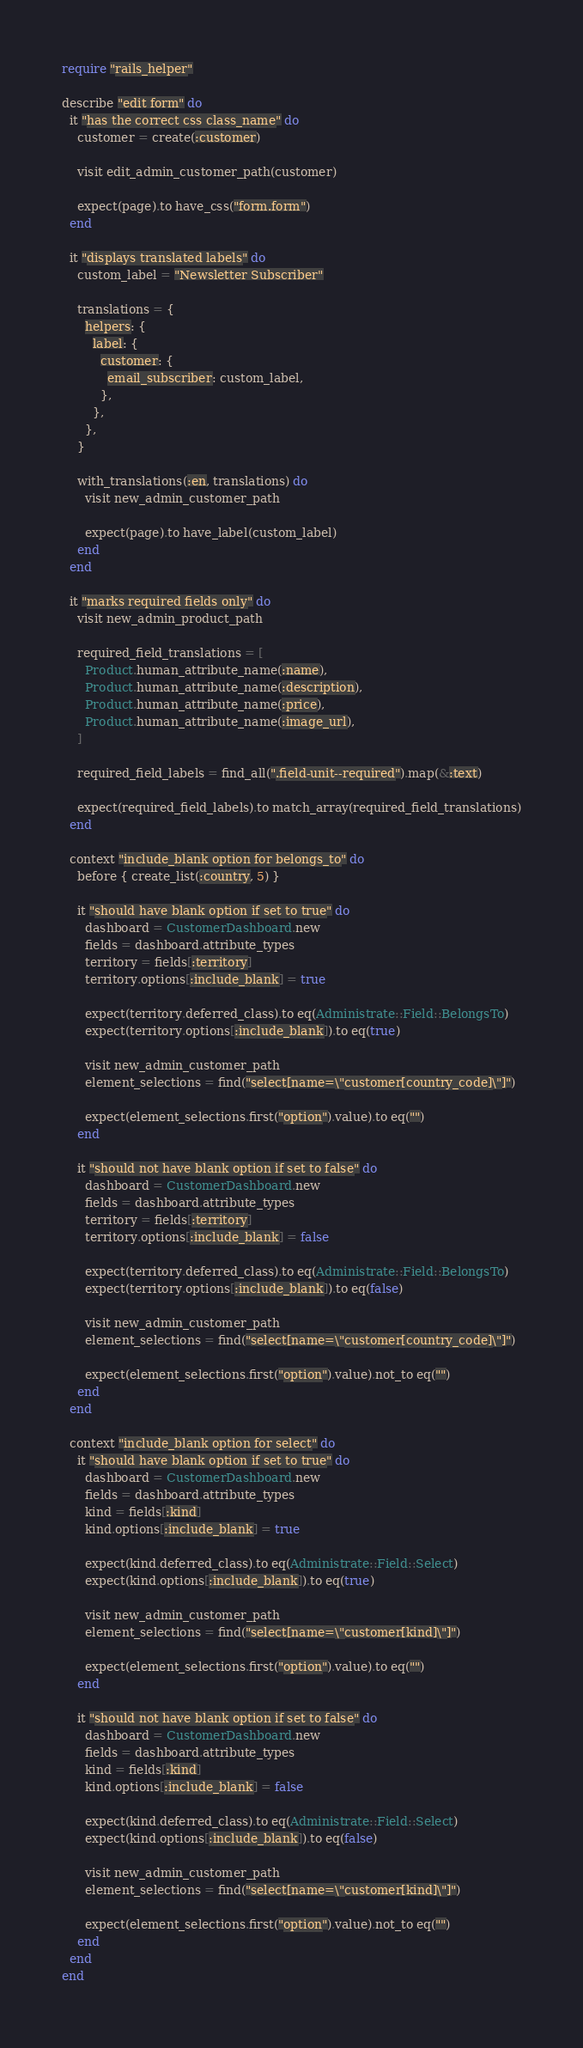Convert code to text. <code><loc_0><loc_0><loc_500><loc_500><_Ruby_>require "rails_helper"

describe "edit form" do
  it "has the correct css class_name" do
    customer = create(:customer)

    visit edit_admin_customer_path(customer)

    expect(page).to have_css("form.form")
  end

  it "displays translated labels" do
    custom_label = "Newsletter Subscriber"

    translations = {
      helpers: {
        label: {
          customer: {
            email_subscriber: custom_label,
          },
        },
      },
    }

    with_translations(:en, translations) do
      visit new_admin_customer_path

      expect(page).to have_label(custom_label)
    end
  end

  it "marks required fields only" do
    visit new_admin_product_path

    required_field_translations = [
      Product.human_attribute_name(:name),
      Product.human_attribute_name(:description),
      Product.human_attribute_name(:price),
      Product.human_attribute_name(:image_url),
    ]

    required_field_labels = find_all(".field-unit--required").map(&:text)

    expect(required_field_labels).to match_array(required_field_translations)
  end

  context "include_blank option for belongs_to" do
    before { create_list(:country, 5) }

    it "should have blank option if set to true" do
      dashboard = CustomerDashboard.new
      fields = dashboard.attribute_types
      territory = fields[:territory]
      territory.options[:include_blank] = true

      expect(territory.deferred_class).to eq(Administrate::Field::BelongsTo)
      expect(territory.options[:include_blank]).to eq(true)

      visit new_admin_customer_path
      element_selections = find("select[name=\"customer[country_code]\"]")

      expect(element_selections.first("option").value).to eq("")
    end

    it "should not have blank option if set to false" do
      dashboard = CustomerDashboard.new
      fields = dashboard.attribute_types
      territory = fields[:territory]
      territory.options[:include_blank] = false

      expect(territory.deferred_class).to eq(Administrate::Field::BelongsTo)
      expect(territory.options[:include_blank]).to eq(false)

      visit new_admin_customer_path
      element_selections = find("select[name=\"customer[country_code]\"]")

      expect(element_selections.first("option").value).not_to eq("")
    end
  end

  context "include_blank option for select" do
    it "should have blank option if set to true" do
      dashboard = CustomerDashboard.new
      fields = dashboard.attribute_types
      kind = fields[:kind]
      kind.options[:include_blank] = true

      expect(kind.deferred_class).to eq(Administrate::Field::Select)
      expect(kind.options[:include_blank]).to eq(true)

      visit new_admin_customer_path
      element_selections = find("select[name=\"customer[kind]\"]")

      expect(element_selections.first("option").value).to eq("")
    end

    it "should not have blank option if set to false" do
      dashboard = CustomerDashboard.new
      fields = dashboard.attribute_types
      kind = fields[:kind]
      kind.options[:include_blank] = false

      expect(kind.deferred_class).to eq(Administrate::Field::Select)
      expect(kind.options[:include_blank]).to eq(false)

      visit new_admin_customer_path
      element_selections = find("select[name=\"customer[kind]\"]")

      expect(element_selections.first("option").value).not_to eq("")
    end
  end
end
</code> 